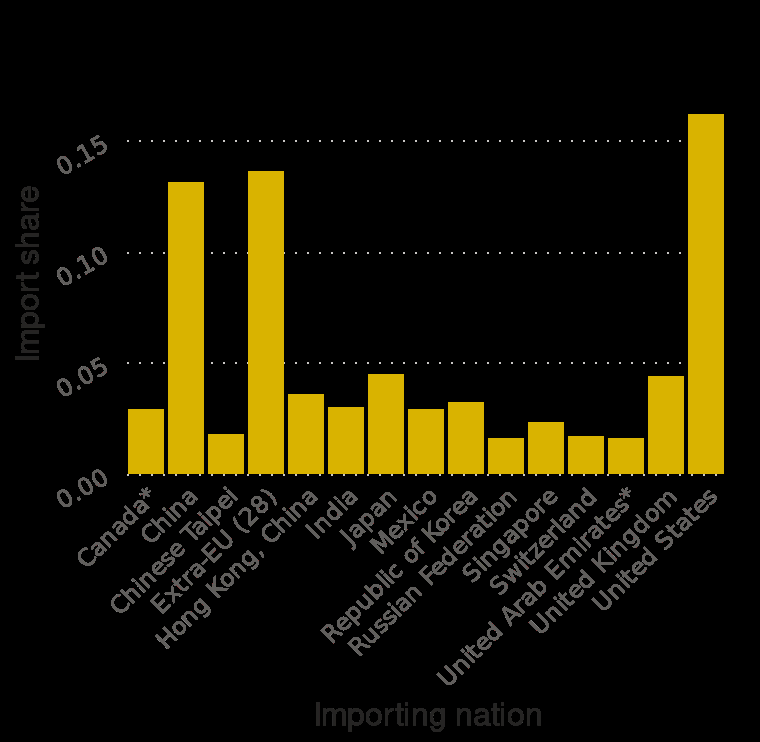<image>
Which country has the largest import share?  The United States. 